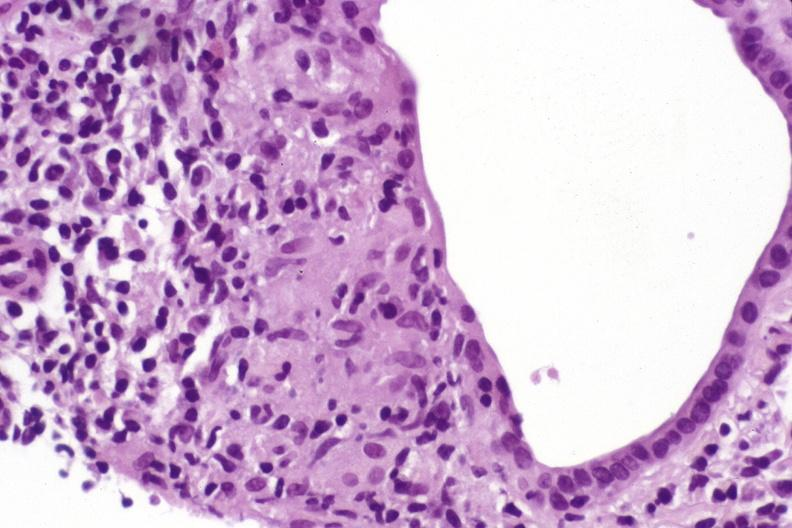does thymus show primary biliary cirrhosis?
Answer the question using a single word or phrase. No 